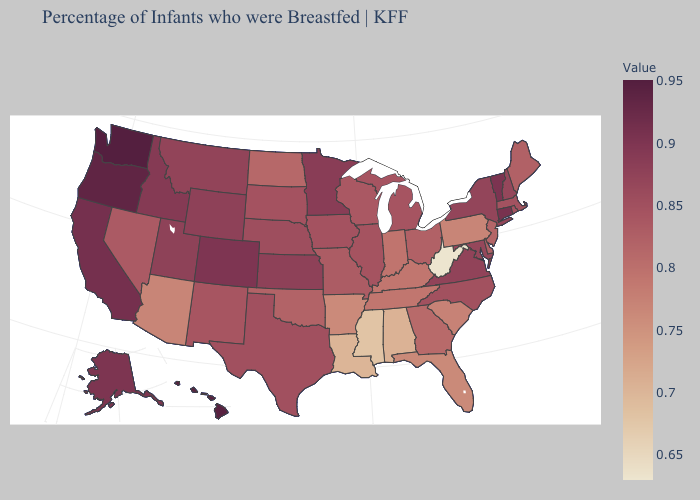Which states have the highest value in the USA?
Keep it brief. Washington. Does the map have missing data?
Concise answer only. No. Does Tennessee have the highest value in the South?
Write a very short answer. No. 